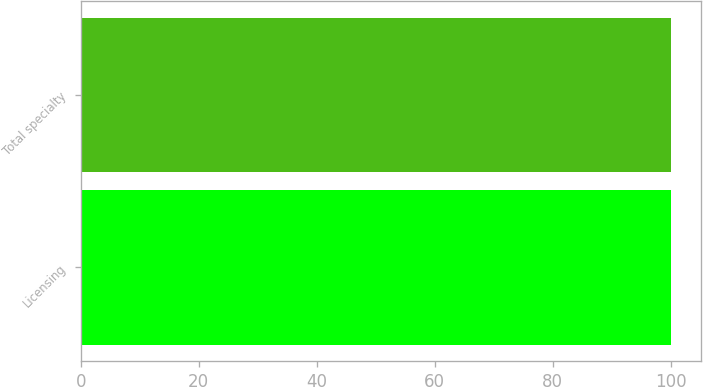Convert chart. <chart><loc_0><loc_0><loc_500><loc_500><bar_chart><fcel>Licensing<fcel>Total specialty<nl><fcel>100<fcel>100.1<nl></chart> 